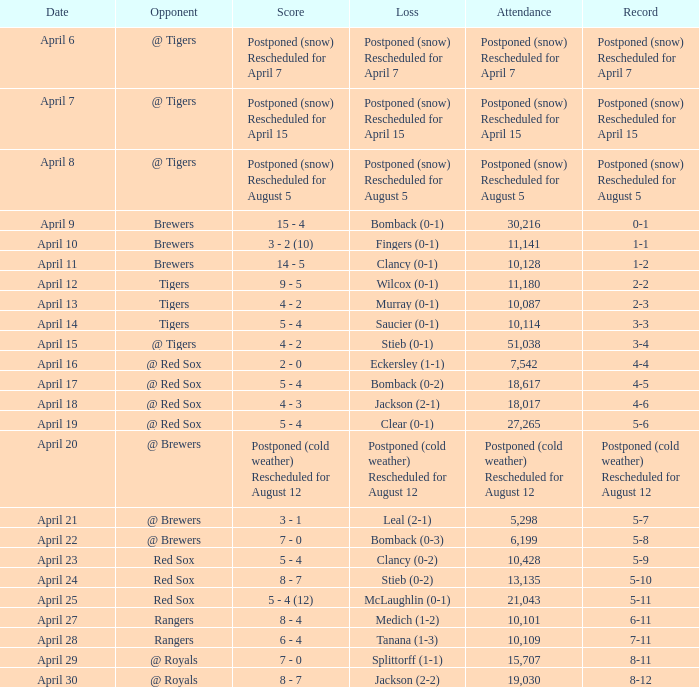Which entry is from april 8? Postponed (snow) Rescheduled for August 5. 